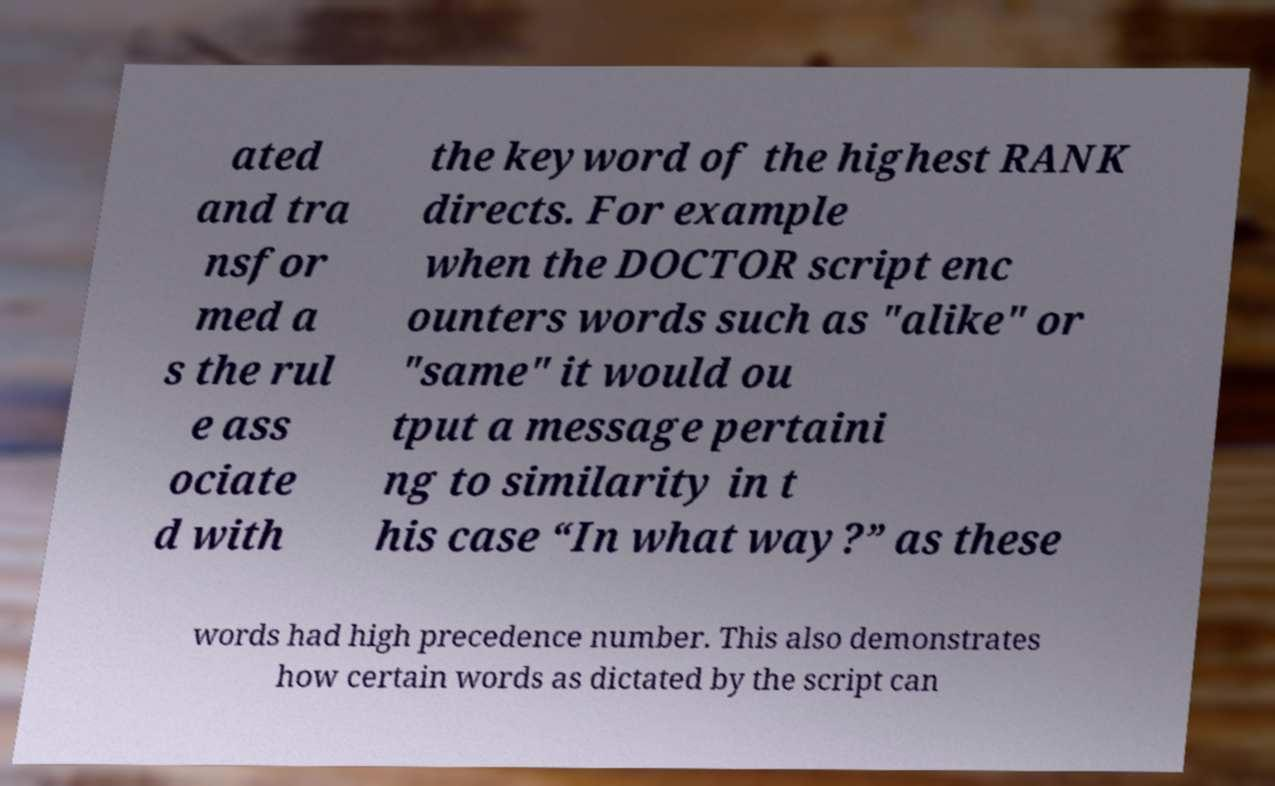Please identify and transcribe the text found in this image. ated and tra nsfor med a s the rul e ass ociate d with the keyword of the highest RANK directs. For example when the DOCTOR script enc ounters words such as "alike" or "same" it would ou tput a message pertaini ng to similarity in t his case “In what way?” as these words had high precedence number. This also demonstrates how certain words as dictated by the script can 